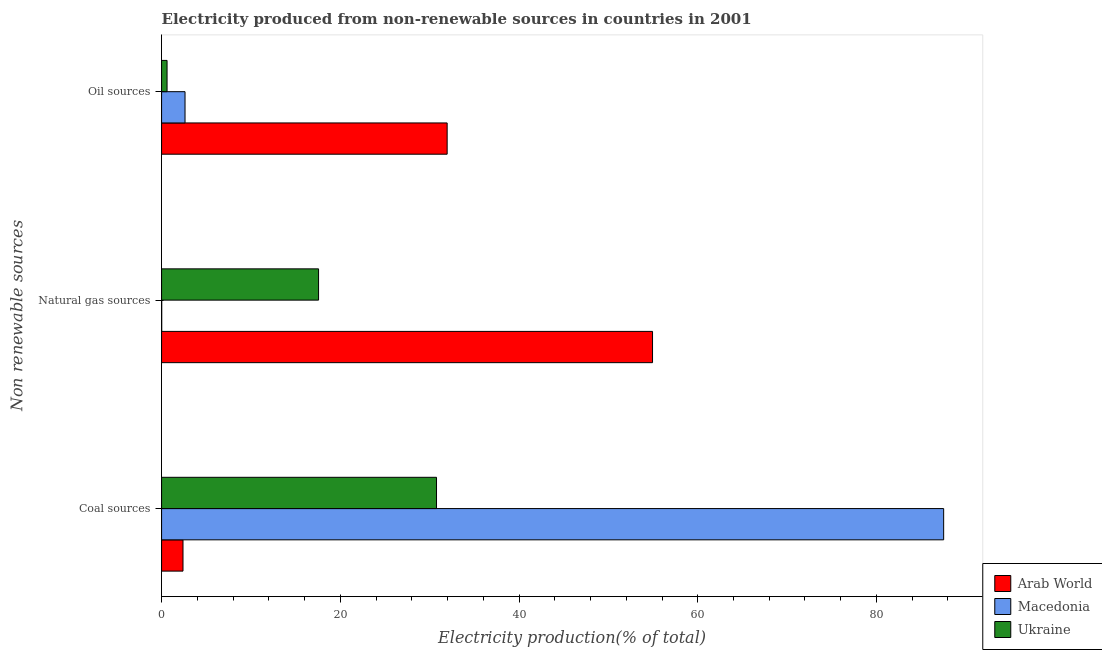How many different coloured bars are there?
Offer a terse response. 3. Are the number of bars on each tick of the Y-axis equal?
Provide a short and direct response. Yes. How many bars are there on the 2nd tick from the bottom?
Ensure brevity in your answer.  3. What is the label of the 2nd group of bars from the top?
Keep it short and to the point. Natural gas sources. What is the percentage of electricity produced by coal in Ukraine?
Make the answer very short. 30.77. Across all countries, what is the maximum percentage of electricity produced by coal?
Offer a very short reply. 87.52. Across all countries, what is the minimum percentage of electricity produced by natural gas?
Offer a terse response. 0.02. In which country was the percentage of electricity produced by oil sources maximum?
Offer a very short reply. Arab World. In which country was the percentage of electricity produced by natural gas minimum?
Keep it short and to the point. Macedonia. What is the total percentage of electricity produced by coal in the graph?
Your answer should be compact. 120.68. What is the difference between the percentage of electricity produced by coal in Ukraine and that in Arab World?
Offer a very short reply. 28.37. What is the difference between the percentage of electricity produced by coal in Arab World and the percentage of electricity produced by oil sources in Ukraine?
Your answer should be compact. 1.78. What is the average percentage of electricity produced by coal per country?
Keep it short and to the point. 40.23. What is the difference between the percentage of electricity produced by natural gas and percentage of electricity produced by coal in Macedonia?
Provide a short and direct response. -87.5. In how many countries, is the percentage of electricity produced by oil sources greater than 80 %?
Provide a succinct answer. 0. What is the ratio of the percentage of electricity produced by coal in Arab World to that in Macedonia?
Offer a very short reply. 0.03. Is the percentage of electricity produced by oil sources in Ukraine less than that in Arab World?
Provide a succinct answer. Yes. What is the difference between the highest and the second highest percentage of electricity produced by oil sources?
Keep it short and to the point. 29.33. What is the difference between the highest and the lowest percentage of electricity produced by coal?
Ensure brevity in your answer.  85.12. In how many countries, is the percentage of electricity produced by coal greater than the average percentage of electricity produced by coal taken over all countries?
Offer a terse response. 1. What does the 1st bar from the top in Oil sources represents?
Offer a terse response. Ukraine. What does the 2nd bar from the bottom in Coal sources represents?
Offer a very short reply. Macedonia. Is it the case that in every country, the sum of the percentage of electricity produced by coal and percentage of electricity produced by natural gas is greater than the percentage of electricity produced by oil sources?
Your answer should be compact. Yes. How many bars are there?
Your answer should be compact. 9. Are all the bars in the graph horizontal?
Provide a succinct answer. Yes. How many countries are there in the graph?
Provide a succinct answer. 3. Does the graph contain grids?
Give a very brief answer. No. How many legend labels are there?
Keep it short and to the point. 3. What is the title of the graph?
Provide a short and direct response. Electricity produced from non-renewable sources in countries in 2001. Does "Sub-Saharan Africa (all income levels)" appear as one of the legend labels in the graph?
Keep it short and to the point. No. What is the label or title of the X-axis?
Ensure brevity in your answer.  Electricity production(% of total). What is the label or title of the Y-axis?
Offer a terse response. Non renewable sources. What is the Electricity production(% of total) in Arab World in Coal sources?
Give a very brief answer. 2.4. What is the Electricity production(% of total) in Macedonia in Coal sources?
Your answer should be compact. 87.52. What is the Electricity production(% of total) of Ukraine in Coal sources?
Keep it short and to the point. 30.77. What is the Electricity production(% of total) in Arab World in Natural gas sources?
Your response must be concise. 54.94. What is the Electricity production(% of total) in Macedonia in Natural gas sources?
Your answer should be compact. 0.02. What is the Electricity production(% of total) in Ukraine in Natural gas sources?
Offer a very short reply. 17.57. What is the Electricity production(% of total) of Arab World in Oil sources?
Your response must be concise. 31.96. What is the Electricity production(% of total) of Macedonia in Oil sources?
Provide a short and direct response. 2.62. What is the Electricity production(% of total) in Ukraine in Oil sources?
Your answer should be compact. 0.61. Across all Non renewable sources, what is the maximum Electricity production(% of total) of Arab World?
Give a very brief answer. 54.94. Across all Non renewable sources, what is the maximum Electricity production(% of total) of Macedonia?
Offer a terse response. 87.52. Across all Non renewable sources, what is the maximum Electricity production(% of total) in Ukraine?
Your answer should be very brief. 30.77. Across all Non renewable sources, what is the minimum Electricity production(% of total) of Arab World?
Offer a terse response. 2.4. Across all Non renewable sources, what is the minimum Electricity production(% of total) of Macedonia?
Provide a succinct answer. 0.02. Across all Non renewable sources, what is the minimum Electricity production(% of total) of Ukraine?
Keep it short and to the point. 0.61. What is the total Electricity production(% of total) of Arab World in the graph?
Offer a very short reply. 89.3. What is the total Electricity production(% of total) in Macedonia in the graph?
Ensure brevity in your answer.  90.16. What is the total Electricity production(% of total) of Ukraine in the graph?
Offer a very short reply. 48.95. What is the difference between the Electricity production(% of total) in Arab World in Coal sources and that in Natural gas sources?
Provide a succinct answer. -52.54. What is the difference between the Electricity production(% of total) of Macedonia in Coal sources and that in Natural gas sources?
Offer a very short reply. 87.5. What is the difference between the Electricity production(% of total) in Ukraine in Coal sources and that in Natural gas sources?
Ensure brevity in your answer.  13.2. What is the difference between the Electricity production(% of total) of Arab World in Coal sources and that in Oil sources?
Give a very brief answer. -29.56. What is the difference between the Electricity production(% of total) in Macedonia in Coal sources and that in Oil sources?
Give a very brief answer. 84.89. What is the difference between the Electricity production(% of total) in Ukraine in Coal sources and that in Oil sources?
Your response must be concise. 30.15. What is the difference between the Electricity production(% of total) in Arab World in Natural gas sources and that in Oil sources?
Offer a terse response. 22.98. What is the difference between the Electricity production(% of total) of Macedonia in Natural gas sources and that in Oil sources?
Offer a terse response. -2.61. What is the difference between the Electricity production(% of total) in Ukraine in Natural gas sources and that in Oil sources?
Make the answer very short. 16.95. What is the difference between the Electricity production(% of total) in Arab World in Coal sources and the Electricity production(% of total) in Macedonia in Natural gas sources?
Give a very brief answer. 2.38. What is the difference between the Electricity production(% of total) of Arab World in Coal sources and the Electricity production(% of total) of Ukraine in Natural gas sources?
Keep it short and to the point. -15.17. What is the difference between the Electricity production(% of total) of Macedonia in Coal sources and the Electricity production(% of total) of Ukraine in Natural gas sources?
Give a very brief answer. 69.95. What is the difference between the Electricity production(% of total) of Arab World in Coal sources and the Electricity production(% of total) of Macedonia in Oil sources?
Give a very brief answer. -0.23. What is the difference between the Electricity production(% of total) of Arab World in Coal sources and the Electricity production(% of total) of Ukraine in Oil sources?
Your response must be concise. 1.78. What is the difference between the Electricity production(% of total) in Macedonia in Coal sources and the Electricity production(% of total) in Ukraine in Oil sources?
Your answer should be very brief. 86.91. What is the difference between the Electricity production(% of total) of Arab World in Natural gas sources and the Electricity production(% of total) of Macedonia in Oil sources?
Your answer should be very brief. 52.32. What is the difference between the Electricity production(% of total) in Arab World in Natural gas sources and the Electricity production(% of total) in Ukraine in Oil sources?
Keep it short and to the point. 54.33. What is the difference between the Electricity production(% of total) of Macedonia in Natural gas sources and the Electricity production(% of total) of Ukraine in Oil sources?
Provide a short and direct response. -0.6. What is the average Electricity production(% of total) of Arab World per Non renewable sources?
Make the answer very short. 29.77. What is the average Electricity production(% of total) in Macedonia per Non renewable sources?
Keep it short and to the point. 30.05. What is the average Electricity production(% of total) of Ukraine per Non renewable sources?
Give a very brief answer. 16.32. What is the difference between the Electricity production(% of total) in Arab World and Electricity production(% of total) in Macedonia in Coal sources?
Provide a succinct answer. -85.12. What is the difference between the Electricity production(% of total) of Arab World and Electricity production(% of total) of Ukraine in Coal sources?
Offer a very short reply. -28.37. What is the difference between the Electricity production(% of total) in Macedonia and Electricity production(% of total) in Ukraine in Coal sources?
Your response must be concise. 56.75. What is the difference between the Electricity production(% of total) of Arab World and Electricity production(% of total) of Macedonia in Natural gas sources?
Give a very brief answer. 54.92. What is the difference between the Electricity production(% of total) of Arab World and Electricity production(% of total) of Ukraine in Natural gas sources?
Ensure brevity in your answer.  37.37. What is the difference between the Electricity production(% of total) of Macedonia and Electricity production(% of total) of Ukraine in Natural gas sources?
Your answer should be compact. -17.55. What is the difference between the Electricity production(% of total) of Arab World and Electricity production(% of total) of Macedonia in Oil sources?
Your answer should be compact. 29.33. What is the difference between the Electricity production(% of total) of Arab World and Electricity production(% of total) of Ukraine in Oil sources?
Provide a succinct answer. 31.34. What is the difference between the Electricity production(% of total) in Macedonia and Electricity production(% of total) in Ukraine in Oil sources?
Your answer should be compact. 2.01. What is the ratio of the Electricity production(% of total) of Arab World in Coal sources to that in Natural gas sources?
Your answer should be compact. 0.04. What is the ratio of the Electricity production(% of total) of Macedonia in Coal sources to that in Natural gas sources?
Ensure brevity in your answer.  5568. What is the ratio of the Electricity production(% of total) in Ukraine in Coal sources to that in Natural gas sources?
Offer a terse response. 1.75. What is the ratio of the Electricity production(% of total) in Arab World in Coal sources to that in Oil sources?
Provide a short and direct response. 0.07. What is the ratio of the Electricity production(% of total) in Macedonia in Coal sources to that in Oil sources?
Your answer should be compact. 33.34. What is the ratio of the Electricity production(% of total) of Ukraine in Coal sources to that in Oil sources?
Ensure brevity in your answer.  50.11. What is the ratio of the Electricity production(% of total) of Arab World in Natural gas sources to that in Oil sources?
Make the answer very short. 1.72. What is the ratio of the Electricity production(% of total) of Macedonia in Natural gas sources to that in Oil sources?
Your response must be concise. 0.01. What is the ratio of the Electricity production(% of total) of Ukraine in Natural gas sources to that in Oil sources?
Your answer should be compact. 28.61. What is the difference between the highest and the second highest Electricity production(% of total) in Arab World?
Keep it short and to the point. 22.98. What is the difference between the highest and the second highest Electricity production(% of total) in Macedonia?
Offer a very short reply. 84.89. What is the difference between the highest and the second highest Electricity production(% of total) of Ukraine?
Your response must be concise. 13.2. What is the difference between the highest and the lowest Electricity production(% of total) in Arab World?
Make the answer very short. 52.54. What is the difference between the highest and the lowest Electricity production(% of total) of Macedonia?
Provide a short and direct response. 87.5. What is the difference between the highest and the lowest Electricity production(% of total) in Ukraine?
Provide a short and direct response. 30.15. 